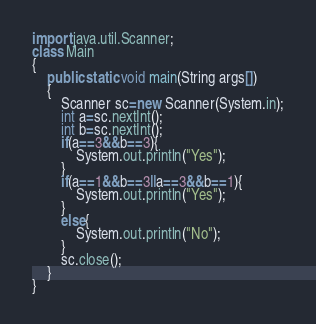<code> <loc_0><loc_0><loc_500><loc_500><_Java_>import java.util.Scanner;
class Main
{
	public static void main(String args[])
	{
		Scanner sc=new Scanner(System.in);
        int a=sc.nextInt();
        int b=sc.nextInt();
        if(a==3&&b==3){
            System.out.println("Yes");
        }
        if(a==1&&b==3||a==3&&b==1){
            System.out.println("Yes");
        }
        else{
            System.out.println("No");
        }
        sc.close();
    }
}</code> 